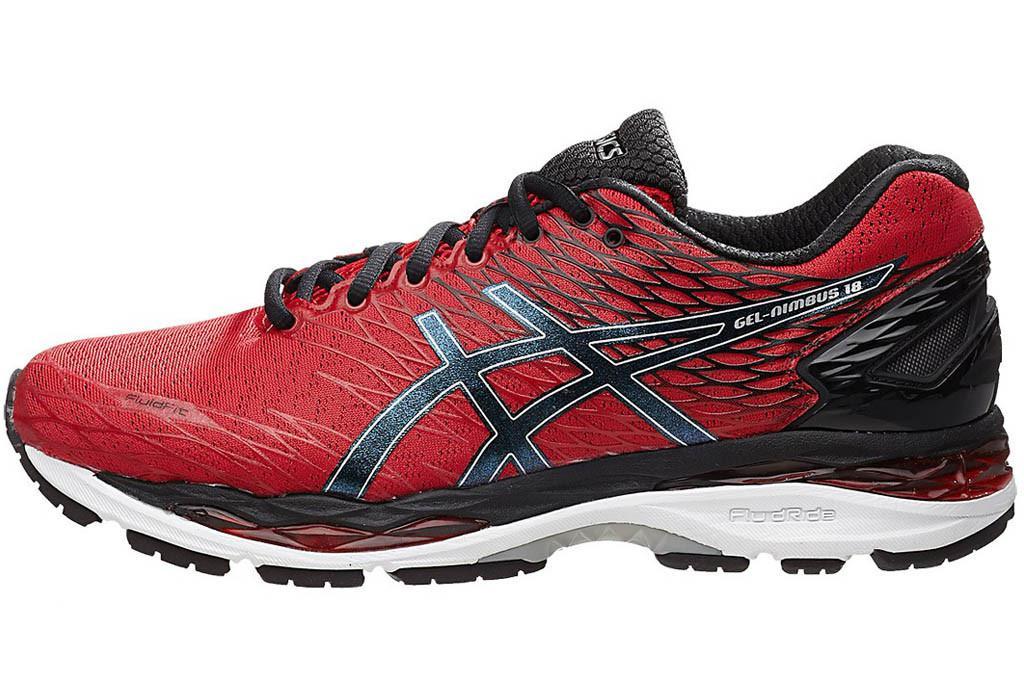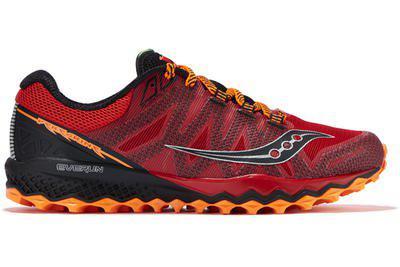The first image is the image on the left, the second image is the image on the right. Assess this claim about the two images: "There are atleast two shoes facing right". Correct or not? Answer yes or no. No. The first image is the image on the left, the second image is the image on the right. Evaluate the accuracy of this statement regarding the images: "Both shoes are pointing to the right.". Is it true? Answer yes or no. No. 